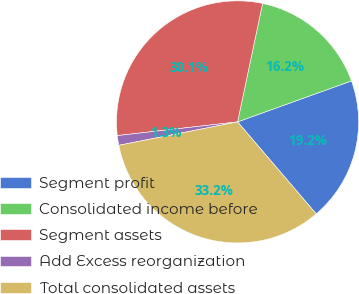Convert chart. <chart><loc_0><loc_0><loc_500><loc_500><pie_chart><fcel>Segment profit<fcel>Consolidated income before<fcel>Segment assets<fcel>Add Excess reorganization<fcel>Total consolidated assets<nl><fcel>19.24%<fcel>16.19%<fcel>30.12%<fcel>1.29%<fcel>33.16%<nl></chart> 